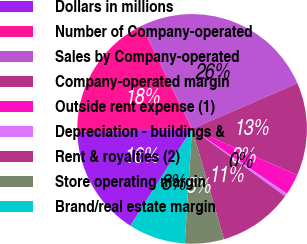Convert chart. <chart><loc_0><loc_0><loc_500><loc_500><pie_chart><fcel>Dollars in millions<fcel>Number of Company-operated<fcel>Sales by Company-operated<fcel>Company-operated margin<fcel>Outside rent expense (1)<fcel>Depreciation - buildings &<fcel>Rent & royalties (2)<fcel>Store operating margin<fcel>Brand/real estate margin<nl><fcel>15.61%<fcel>18.14%<fcel>25.73%<fcel>13.08%<fcel>2.96%<fcel>0.43%<fcel>10.55%<fcel>5.49%<fcel>8.02%<nl></chart> 